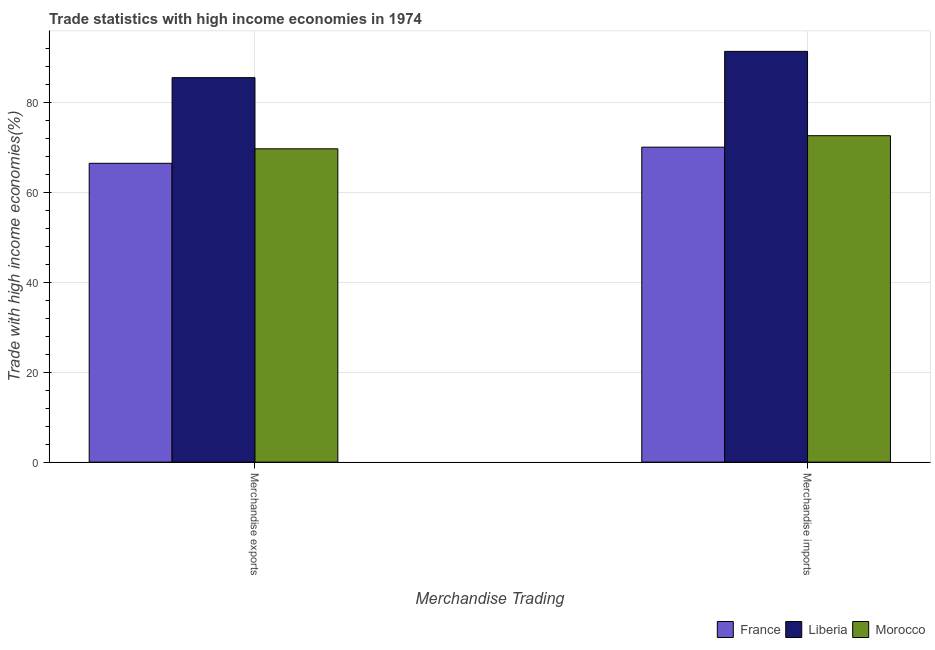Are the number of bars on each tick of the X-axis equal?
Make the answer very short. Yes. What is the merchandise exports in Morocco?
Provide a succinct answer. 69.72. Across all countries, what is the maximum merchandise imports?
Make the answer very short. 91.4. Across all countries, what is the minimum merchandise imports?
Offer a very short reply. 70.08. In which country was the merchandise imports maximum?
Offer a terse response. Liberia. In which country was the merchandise exports minimum?
Keep it short and to the point. France. What is the total merchandise imports in the graph?
Keep it short and to the point. 234.12. What is the difference between the merchandise exports in Liberia and that in France?
Ensure brevity in your answer.  19.06. What is the difference between the merchandise imports in France and the merchandise exports in Liberia?
Your answer should be very brief. -15.47. What is the average merchandise exports per country?
Provide a succinct answer. 73.92. What is the difference between the merchandise exports and merchandise imports in Morocco?
Provide a short and direct response. -2.92. What is the ratio of the merchandise exports in France to that in Morocco?
Offer a very short reply. 0.95. Is the merchandise exports in Morocco less than that in France?
Your response must be concise. No. In how many countries, is the merchandise exports greater than the average merchandise exports taken over all countries?
Offer a terse response. 1. What does the 2nd bar from the left in Merchandise imports represents?
Provide a succinct answer. Liberia. What does the 1st bar from the right in Merchandise imports represents?
Make the answer very short. Morocco. How many bars are there?
Make the answer very short. 6. How many countries are there in the graph?
Ensure brevity in your answer.  3. What is the difference between two consecutive major ticks on the Y-axis?
Provide a short and direct response. 20. Does the graph contain grids?
Provide a short and direct response. Yes. Where does the legend appear in the graph?
Make the answer very short. Bottom right. How are the legend labels stacked?
Offer a very short reply. Horizontal. What is the title of the graph?
Make the answer very short. Trade statistics with high income economies in 1974. What is the label or title of the X-axis?
Offer a terse response. Merchandise Trading. What is the label or title of the Y-axis?
Give a very brief answer. Trade with high income economies(%). What is the Trade with high income economies(%) of France in Merchandise exports?
Your answer should be very brief. 66.49. What is the Trade with high income economies(%) in Liberia in Merchandise exports?
Your response must be concise. 85.55. What is the Trade with high income economies(%) in Morocco in Merchandise exports?
Ensure brevity in your answer.  69.72. What is the Trade with high income economies(%) in France in Merchandise imports?
Provide a short and direct response. 70.08. What is the Trade with high income economies(%) of Liberia in Merchandise imports?
Offer a very short reply. 91.4. What is the Trade with high income economies(%) in Morocco in Merchandise imports?
Make the answer very short. 72.64. Across all Merchandise Trading, what is the maximum Trade with high income economies(%) in France?
Your answer should be compact. 70.08. Across all Merchandise Trading, what is the maximum Trade with high income economies(%) in Liberia?
Give a very brief answer. 91.4. Across all Merchandise Trading, what is the maximum Trade with high income economies(%) of Morocco?
Your answer should be compact. 72.64. Across all Merchandise Trading, what is the minimum Trade with high income economies(%) in France?
Provide a succinct answer. 66.49. Across all Merchandise Trading, what is the minimum Trade with high income economies(%) in Liberia?
Offer a very short reply. 85.55. Across all Merchandise Trading, what is the minimum Trade with high income economies(%) of Morocco?
Give a very brief answer. 69.72. What is the total Trade with high income economies(%) of France in the graph?
Provide a short and direct response. 136.57. What is the total Trade with high income economies(%) of Liberia in the graph?
Provide a short and direct response. 176.95. What is the total Trade with high income economies(%) in Morocco in the graph?
Your response must be concise. 142.35. What is the difference between the Trade with high income economies(%) in France in Merchandise exports and that in Merchandise imports?
Make the answer very short. -3.59. What is the difference between the Trade with high income economies(%) of Liberia in Merchandise exports and that in Merchandise imports?
Make the answer very short. -5.85. What is the difference between the Trade with high income economies(%) in Morocco in Merchandise exports and that in Merchandise imports?
Give a very brief answer. -2.92. What is the difference between the Trade with high income economies(%) of France in Merchandise exports and the Trade with high income economies(%) of Liberia in Merchandise imports?
Your answer should be very brief. -24.91. What is the difference between the Trade with high income economies(%) in France in Merchandise exports and the Trade with high income economies(%) in Morocco in Merchandise imports?
Give a very brief answer. -6.15. What is the difference between the Trade with high income economies(%) in Liberia in Merchandise exports and the Trade with high income economies(%) in Morocco in Merchandise imports?
Keep it short and to the point. 12.91. What is the average Trade with high income economies(%) of France per Merchandise Trading?
Your answer should be compact. 68.29. What is the average Trade with high income economies(%) in Liberia per Merchandise Trading?
Offer a terse response. 88.48. What is the average Trade with high income economies(%) of Morocco per Merchandise Trading?
Provide a succinct answer. 71.18. What is the difference between the Trade with high income economies(%) of France and Trade with high income economies(%) of Liberia in Merchandise exports?
Offer a very short reply. -19.06. What is the difference between the Trade with high income economies(%) in France and Trade with high income economies(%) in Morocco in Merchandise exports?
Keep it short and to the point. -3.22. What is the difference between the Trade with high income economies(%) in Liberia and Trade with high income economies(%) in Morocco in Merchandise exports?
Provide a succinct answer. 15.84. What is the difference between the Trade with high income economies(%) of France and Trade with high income economies(%) of Liberia in Merchandise imports?
Offer a very short reply. -21.32. What is the difference between the Trade with high income economies(%) of France and Trade with high income economies(%) of Morocco in Merchandise imports?
Your answer should be very brief. -2.55. What is the difference between the Trade with high income economies(%) in Liberia and Trade with high income economies(%) in Morocco in Merchandise imports?
Your answer should be compact. 18.76. What is the ratio of the Trade with high income economies(%) of France in Merchandise exports to that in Merchandise imports?
Provide a short and direct response. 0.95. What is the ratio of the Trade with high income economies(%) of Liberia in Merchandise exports to that in Merchandise imports?
Offer a terse response. 0.94. What is the ratio of the Trade with high income economies(%) in Morocco in Merchandise exports to that in Merchandise imports?
Provide a succinct answer. 0.96. What is the difference between the highest and the second highest Trade with high income economies(%) in France?
Give a very brief answer. 3.59. What is the difference between the highest and the second highest Trade with high income economies(%) in Liberia?
Ensure brevity in your answer.  5.85. What is the difference between the highest and the second highest Trade with high income economies(%) in Morocco?
Offer a very short reply. 2.92. What is the difference between the highest and the lowest Trade with high income economies(%) of France?
Ensure brevity in your answer.  3.59. What is the difference between the highest and the lowest Trade with high income economies(%) in Liberia?
Give a very brief answer. 5.85. What is the difference between the highest and the lowest Trade with high income economies(%) of Morocco?
Your response must be concise. 2.92. 